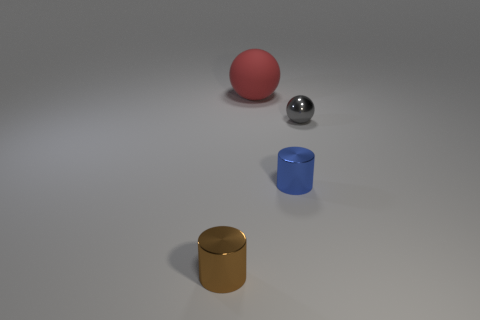Subtract 1 balls. How many balls are left? 1 Subtract all brown cylinders. How many cylinders are left? 1 Add 1 tiny blue objects. How many objects exist? 5 Add 2 big matte balls. How many big matte balls exist? 3 Subtract 0 brown balls. How many objects are left? 4 Subtract all gray balls. Subtract all blue blocks. How many balls are left? 1 Subtract all red blocks. How many red balls are left? 1 Subtract all large blue balls. Subtract all metal cylinders. How many objects are left? 2 Add 3 tiny brown metal cylinders. How many tiny brown metal cylinders are left? 4 